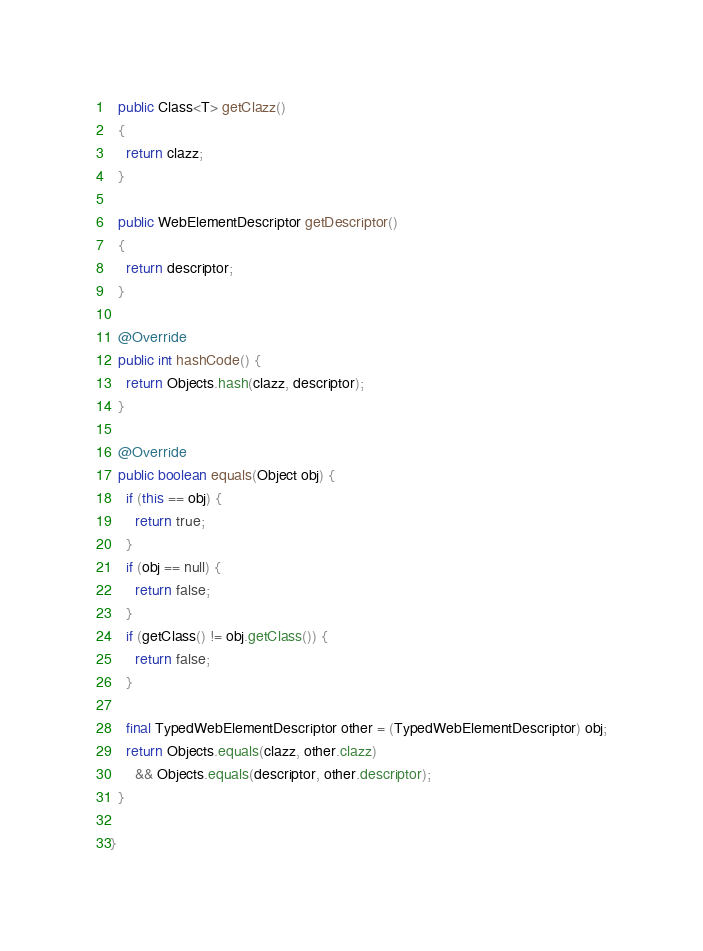<code> <loc_0><loc_0><loc_500><loc_500><_Java_>  public Class<T> getClazz()
  {
    return clazz;
  }

  public WebElementDescriptor getDescriptor()
  {
    return descriptor;
  }
  
  @Override
  public int hashCode() {
    return Objects.hash(clazz, descriptor);
  }

  @Override
  public boolean equals(Object obj) {
    if (this == obj) {
      return true;
    }
    if (obj == null) {
      return false;
    }
    if (getClass() != obj.getClass()) {
      return false;
    }
    
    final TypedWebElementDescriptor other = (TypedWebElementDescriptor) obj;
    return Objects.equals(clazz, other.clazz)
      && Objects.equals(descriptor, other.descriptor);
  }
  
}
</code> 